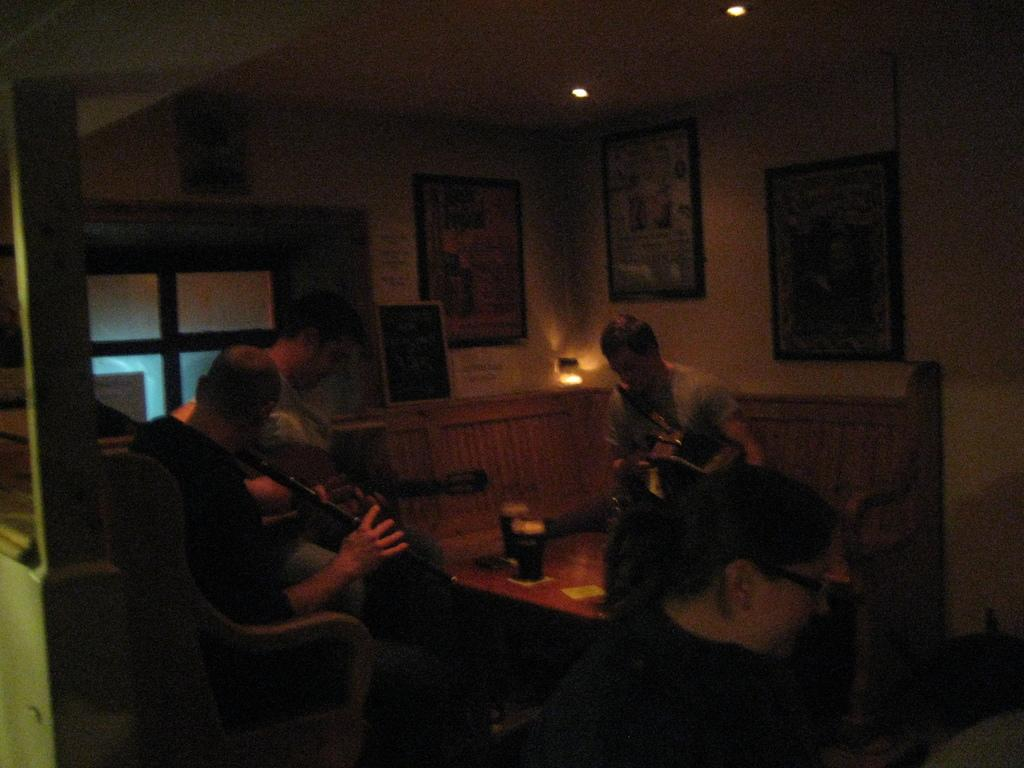What are the people in the image doing? There are persons sitting on chairs in the image. What objects are on the table in the image? There are glasses on a table in the image. What can be seen on the wall in the image? There are pictures on a wall in the image. What can be seen in the distance in the image? There is a light visible in the distance in the image. How many robins are sitting on the chairs in the image? There are no robins present in the image; it features persons sitting on chairs. What type of hall is depicted in the image? There is no hall depicted in the image; it shows persons sitting on chairs, glasses on a table, pictures on a wall, and a light in the distance. 